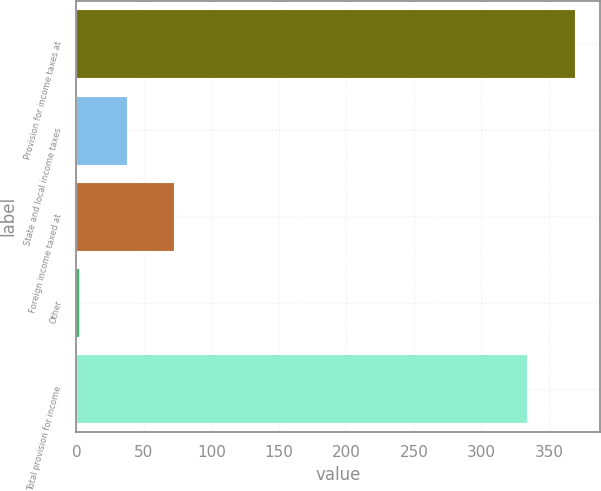Convert chart to OTSL. <chart><loc_0><loc_0><loc_500><loc_500><bar_chart><fcel>Provision for income taxes at<fcel>State and local income taxes<fcel>Foreign income taxed at<fcel>Other<fcel>Total provision for income<nl><fcel>369.44<fcel>37.24<fcel>72.58<fcel>1.9<fcel>334.1<nl></chart> 